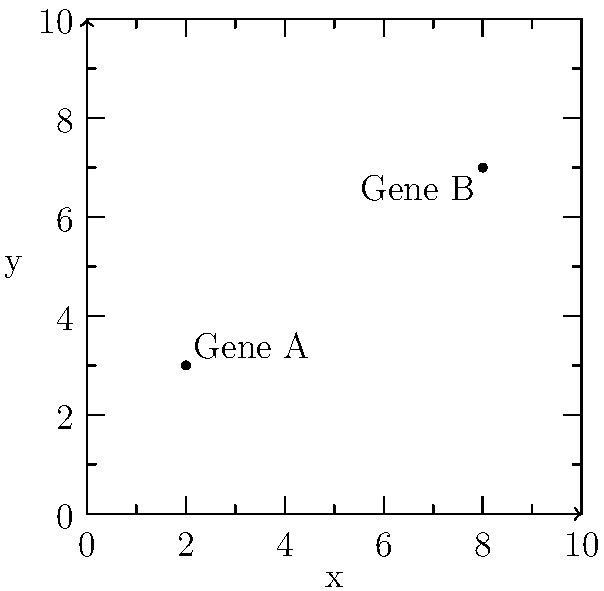In a 2D representation of a chromosome segment, two gene loci are plotted as points on a coordinate system. Gene A is located at (2, 3) and Gene B is at (8, 7). Calculate the distance between these two gene loci to determine their physical proximity on the chromosome. Round your answer to two decimal places. To calculate the distance between two points in a 2D plane, we use the distance formula derived from the Pythagorean theorem:

$$d = \sqrt{(x_2 - x_1)^2 + (y_2 - y_1)^2}$$

Where $(x_1, y_1)$ represents the coordinates of the first point (Gene A) and $(x_2, y_2)$ represents the coordinates of the second point (Gene B).

Given:
Gene A: $(x_1, y_1) = (2, 3)$
Gene B: $(x_2, y_2) = (8, 7)$

Step 1: Substitute the values into the distance formula:
$$d = \sqrt{(8 - 2)^2 + (7 - 3)^2}$$

Step 2: Simplify the expressions inside the parentheses:
$$d = \sqrt{6^2 + 4^2}$$

Step 3: Calculate the squares:
$$d = \sqrt{36 + 16}$$

Step 4: Add the values under the square root:
$$d = \sqrt{52}$$

Step 5: Calculate the square root and round to two decimal places:
$$d \approx 7.21$$

Therefore, the distance between Gene A and Gene B is approximately 7.21 units on this 2D representation of the chromosome segment.
Answer: 7.21 units 